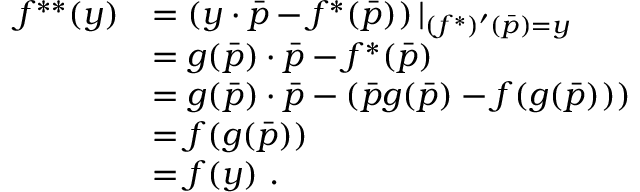<formula> <loc_0><loc_0><loc_500><loc_500>{ \begin{array} { r l } { f ^ { * * } ( y ) } & { = \left ( y \cdot { \bar { p } } - f ^ { * } ( { \bar { p } } ) \right ) | _ { ( f ^ { * } ) ^ { \prime } ( { \bar { p } } ) = y } } \\ & { = g ( { \bar { p } } ) \cdot { \bar { p } } - f ^ { * } ( { \bar { p } } ) } \\ & { = g ( { \bar { p } } ) \cdot { \bar { p } } - ( { \bar { p } } g ( { \bar { p } } ) - f ( g ( { \bar { p } } ) ) ) } \\ & { = f ( g ( { \bar { p } } ) ) } \\ & { = f ( y ) . } \end{array} }</formula> 